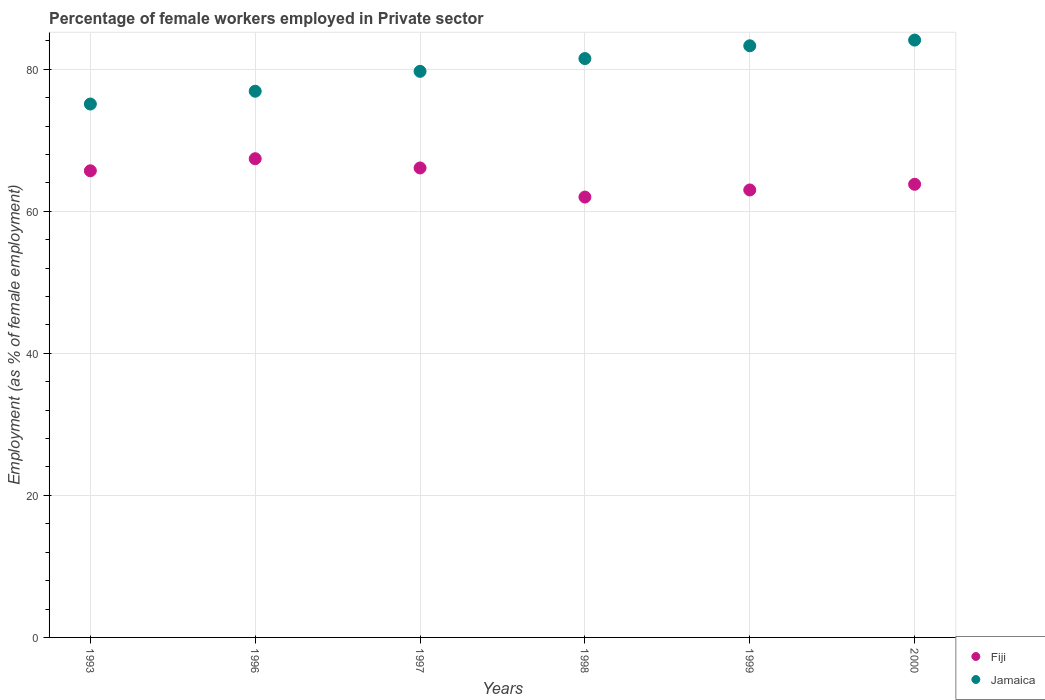How many different coloured dotlines are there?
Give a very brief answer. 2. Is the number of dotlines equal to the number of legend labels?
Keep it short and to the point. Yes. What is the percentage of females employed in Private sector in Jamaica in 1998?
Your answer should be compact. 81.5. Across all years, what is the maximum percentage of females employed in Private sector in Jamaica?
Offer a very short reply. 84.1. Across all years, what is the minimum percentage of females employed in Private sector in Jamaica?
Provide a succinct answer. 75.1. In which year was the percentage of females employed in Private sector in Jamaica maximum?
Your answer should be compact. 2000. In which year was the percentage of females employed in Private sector in Jamaica minimum?
Your answer should be compact. 1993. What is the total percentage of females employed in Private sector in Jamaica in the graph?
Make the answer very short. 480.6. What is the difference between the percentage of females employed in Private sector in Fiji in 1993 and that in 2000?
Give a very brief answer. 1.9. What is the difference between the percentage of females employed in Private sector in Fiji in 1998 and the percentage of females employed in Private sector in Jamaica in 1996?
Offer a terse response. -14.9. What is the average percentage of females employed in Private sector in Jamaica per year?
Your answer should be very brief. 80.1. In the year 1996, what is the difference between the percentage of females employed in Private sector in Jamaica and percentage of females employed in Private sector in Fiji?
Make the answer very short. 9.5. What is the ratio of the percentage of females employed in Private sector in Jamaica in 1993 to that in 1997?
Your answer should be very brief. 0.94. Is the percentage of females employed in Private sector in Jamaica in 1996 less than that in 1998?
Keep it short and to the point. Yes. Is the difference between the percentage of females employed in Private sector in Jamaica in 1998 and 2000 greater than the difference between the percentage of females employed in Private sector in Fiji in 1998 and 2000?
Ensure brevity in your answer.  No. What is the difference between the highest and the second highest percentage of females employed in Private sector in Fiji?
Your answer should be very brief. 1.3. What is the difference between the highest and the lowest percentage of females employed in Private sector in Fiji?
Provide a succinct answer. 5.4. In how many years, is the percentage of females employed in Private sector in Fiji greater than the average percentage of females employed in Private sector in Fiji taken over all years?
Provide a short and direct response. 3. Does the percentage of females employed in Private sector in Fiji monotonically increase over the years?
Offer a very short reply. No. Is the percentage of females employed in Private sector in Jamaica strictly greater than the percentage of females employed in Private sector in Fiji over the years?
Your response must be concise. Yes. How many dotlines are there?
Provide a short and direct response. 2. What is the difference between two consecutive major ticks on the Y-axis?
Offer a very short reply. 20. Where does the legend appear in the graph?
Offer a terse response. Bottom right. How are the legend labels stacked?
Your answer should be compact. Vertical. What is the title of the graph?
Give a very brief answer. Percentage of female workers employed in Private sector. What is the label or title of the X-axis?
Offer a very short reply. Years. What is the label or title of the Y-axis?
Offer a very short reply. Employment (as % of female employment). What is the Employment (as % of female employment) in Fiji in 1993?
Your answer should be very brief. 65.7. What is the Employment (as % of female employment) of Jamaica in 1993?
Your answer should be compact. 75.1. What is the Employment (as % of female employment) in Fiji in 1996?
Your answer should be very brief. 67.4. What is the Employment (as % of female employment) in Jamaica in 1996?
Your answer should be compact. 76.9. What is the Employment (as % of female employment) in Fiji in 1997?
Give a very brief answer. 66.1. What is the Employment (as % of female employment) in Jamaica in 1997?
Your answer should be very brief. 79.7. What is the Employment (as % of female employment) in Fiji in 1998?
Provide a short and direct response. 62. What is the Employment (as % of female employment) of Jamaica in 1998?
Provide a succinct answer. 81.5. What is the Employment (as % of female employment) of Fiji in 1999?
Provide a succinct answer. 63. What is the Employment (as % of female employment) in Jamaica in 1999?
Make the answer very short. 83.3. What is the Employment (as % of female employment) of Fiji in 2000?
Your response must be concise. 63.8. What is the Employment (as % of female employment) of Jamaica in 2000?
Ensure brevity in your answer.  84.1. Across all years, what is the maximum Employment (as % of female employment) of Fiji?
Provide a short and direct response. 67.4. Across all years, what is the maximum Employment (as % of female employment) of Jamaica?
Keep it short and to the point. 84.1. Across all years, what is the minimum Employment (as % of female employment) of Fiji?
Offer a terse response. 62. Across all years, what is the minimum Employment (as % of female employment) in Jamaica?
Your answer should be very brief. 75.1. What is the total Employment (as % of female employment) of Fiji in the graph?
Your response must be concise. 388. What is the total Employment (as % of female employment) in Jamaica in the graph?
Ensure brevity in your answer.  480.6. What is the difference between the Employment (as % of female employment) in Fiji in 1993 and that in 1996?
Your answer should be compact. -1.7. What is the difference between the Employment (as % of female employment) of Jamaica in 1993 and that in 1996?
Your answer should be compact. -1.8. What is the difference between the Employment (as % of female employment) of Jamaica in 1993 and that in 1997?
Provide a short and direct response. -4.6. What is the difference between the Employment (as % of female employment) of Fiji in 1993 and that in 1998?
Give a very brief answer. 3.7. What is the difference between the Employment (as % of female employment) in Fiji in 1993 and that in 2000?
Your answer should be very brief. 1.9. What is the difference between the Employment (as % of female employment) of Fiji in 1996 and that in 1998?
Give a very brief answer. 5.4. What is the difference between the Employment (as % of female employment) of Jamaica in 1996 and that in 1998?
Offer a terse response. -4.6. What is the difference between the Employment (as % of female employment) in Fiji in 1996 and that in 2000?
Give a very brief answer. 3.6. What is the difference between the Employment (as % of female employment) in Fiji in 1997 and that in 1998?
Your response must be concise. 4.1. What is the difference between the Employment (as % of female employment) in Jamaica in 1997 and that in 1998?
Your answer should be compact. -1.8. What is the difference between the Employment (as % of female employment) in Fiji in 1998 and that in 1999?
Offer a very short reply. -1. What is the difference between the Employment (as % of female employment) of Jamaica in 1999 and that in 2000?
Make the answer very short. -0.8. What is the difference between the Employment (as % of female employment) in Fiji in 1993 and the Employment (as % of female employment) in Jamaica in 1996?
Provide a succinct answer. -11.2. What is the difference between the Employment (as % of female employment) of Fiji in 1993 and the Employment (as % of female employment) of Jamaica in 1998?
Your answer should be very brief. -15.8. What is the difference between the Employment (as % of female employment) in Fiji in 1993 and the Employment (as % of female employment) in Jamaica in 1999?
Make the answer very short. -17.6. What is the difference between the Employment (as % of female employment) in Fiji in 1993 and the Employment (as % of female employment) in Jamaica in 2000?
Provide a short and direct response. -18.4. What is the difference between the Employment (as % of female employment) in Fiji in 1996 and the Employment (as % of female employment) in Jamaica in 1998?
Provide a succinct answer. -14.1. What is the difference between the Employment (as % of female employment) of Fiji in 1996 and the Employment (as % of female employment) of Jamaica in 1999?
Your response must be concise. -15.9. What is the difference between the Employment (as % of female employment) in Fiji in 1996 and the Employment (as % of female employment) in Jamaica in 2000?
Provide a succinct answer. -16.7. What is the difference between the Employment (as % of female employment) of Fiji in 1997 and the Employment (as % of female employment) of Jamaica in 1998?
Offer a terse response. -15.4. What is the difference between the Employment (as % of female employment) of Fiji in 1997 and the Employment (as % of female employment) of Jamaica in 1999?
Your answer should be compact. -17.2. What is the difference between the Employment (as % of female employment) of Fiji in 1998 and the Employment (as % of female employment) of Jamaica in 1999?
Ensure brevity in your answer.  -21.3. What is the difference between the Employment (as % of female employment) of Fiji in 1998 and the Employment (as % of female employment) of Jamaica in 2000?
Provide a succinct answer. -22.1. What is the difference between the Employment (as % of female employment) of Fiji in 1999 and the Employment (as % of female employment) of Jamaica in 2000?
Keep it short and to the point. -21.1. What is the average Employment (as % of female employment) of Fiji per year?
Provide a succinct answer. 64.67. What is the average Employment (as % of female employment) of Jamaica per year?
Your answer should be compact. 80.1. In the year 1993, what is the difference between the Employment (as % of female employment) of Fiji and Employment (as % of female employment) of Jamaica?
Provide a succinct answer. -9.4. In the year 1997, what is the difference between the Employment (as % of female employment) of Fiji and Employment (as % of female employment) of Jamaica?
Your response must be concise. -13.6. In the year 1998, what is the difference between the Employment (as % of female employment) of Fiji and Employment (as % of female employment) of Jamaica?
Your response must be concise. -19.5. In the year 1999, what is the difference between the Employment (as % of female employment) in Fiji and Employment (as % of female employment) in Jamaica?
Provide a short and direct response. -20.3. In the year 2000, what is the difference between the Employment (as % of female employment) of Fiji and Employment (as % of female employment) of Jamaica?
Make the answer very short. -20.3. What is the ratio of the Employment (as % of female employment) of Fiji in 1993 to that in 1996?
Offer a terse response. 0.97. What is the ratio of the Employment (as % of female employment) in Jamaica in 1993 to that in 1996?
Provide a succinct answer. 0.98. What is the ratio of the Employment (as % of female employment) in Fiji in 1993 to that in 1997?
Offer a terse response. 0.99. What is the ratio of the Employment (as % of female employment) of Jamaica in 1993 to that in 1997?
Offer a terse response. 0.94. What is the ratio of the Employment (as % of female employment) of Fiji in 1993 to that in 1998?
Keep it short and to the point. 1.06. What is the ratio of the Employment (as % of female employment) in Jamaica in 1993 to that in 1998?
Give a very brief answer. 0.92. What is the ratio of the Employment (as % of female employment) in Fiji in 1993 to that in 1999?
Keep it short and to the point. 1.04. What is the ratio of the Employment (as % of female employment) in Jamaica in 1993 to that in 1999?
Keep it short and to the point. 0.9. What is the ratio of the Employment (as % of female employment) in Fiji in 1993 to that in 2000?
Keep it short and to the point. 1.03. What is the ratio of the Employment (as % of female employment) in Jamaica in 1993 to that in 2000?
Provide a succinct answer. 0.89. What is the ratio of the Employment (as % of female employment) in Fiji in 1996 to that in 1997?
Offer a terse response. 1.02. What is the ratio of the Employment (as % of female employment) of Jamaica in 1996 to that in 1997?
Your answer should be very brief. 0.96. What is the ratio of the Employment (as % of female employment) of Fiji in 1996 to that in 1998?
Offer a very short reply. 1.09. What is the ratio of the Employment (as % of female employment) in Jamaica in 1996 to that in 1998?
Keep it short and to the point. 0.94. What is the ratio of the Employment (as % of female employment) of Fiji in 1996 to that in 1999?
Your response must be concise. 1.07. What is the ratio of the Employment (as % of female employment) in Jamaica in 1996 to that in 1999?
Offer a very short reply. 0.92. What is the ratio of the Employment (as % of female employment) of Fiji in 1996 to that in 2000?
Keep it short and to the point. 1.06. What is the ratio of the Employment (as % of female employment) of Jamaica in 1996 to that in 2000?
Your answer should be compact. 0.91. What is the ratio of the Employment (as % of female employment) of Fiji in 1997 to that in 1998?
Your response must be concise. 1.07. What is the ratio of the Employment (as % of female employment) in Jamaica in 1997 to that in 1998?
Your answer should be compact. 0.98. What is the ratio of the Employment (as % of female employment) of Fiji in 1997 to that in 1999?
Your answer should be compact. 1.05. What is the ratio of the Employment (as % of female employment) of Jamaica in 1997 to that in 1999?
Keep it short and to the point. 0.96. What is the ratio of the Employment (as % of female employment) of Fiji in 1997 to that in 2000?
Offer a terse response. 1.04. What is the ratio of the Employment (as % of female employment) in Jamaica in 1997 to that in 2000?
Keep it short and to the point. 0.95. What is the ratio of the Employment (as % of female employment) of Fiji in 1998 to that in 1999?
Offer a terse response. 0.98. What is the ratio of the Employment (as % of female employment) in Jamaica in 1998 to that in 1999?
Offer a very short reply. 0.98. What is the ratio of the Employment (as % of female employment) in Fiji in 1998 to that in 2000?
Your answer should be compact. 0.97. What is the ratio of the Employment (as % of female employment) of Jamaica in 1998 to that in 2000?
Make the answer very short. 0.97. What is the ratio of the Employment (as % of female employment) of Fiji in 1999 to that in 2000?
Your response must be concise. 0.99. What is the ratio of the Employment (as % of female employment) in Jamaica in 1999 to that in 2000?
Your answer should be very brief. 0.99. 